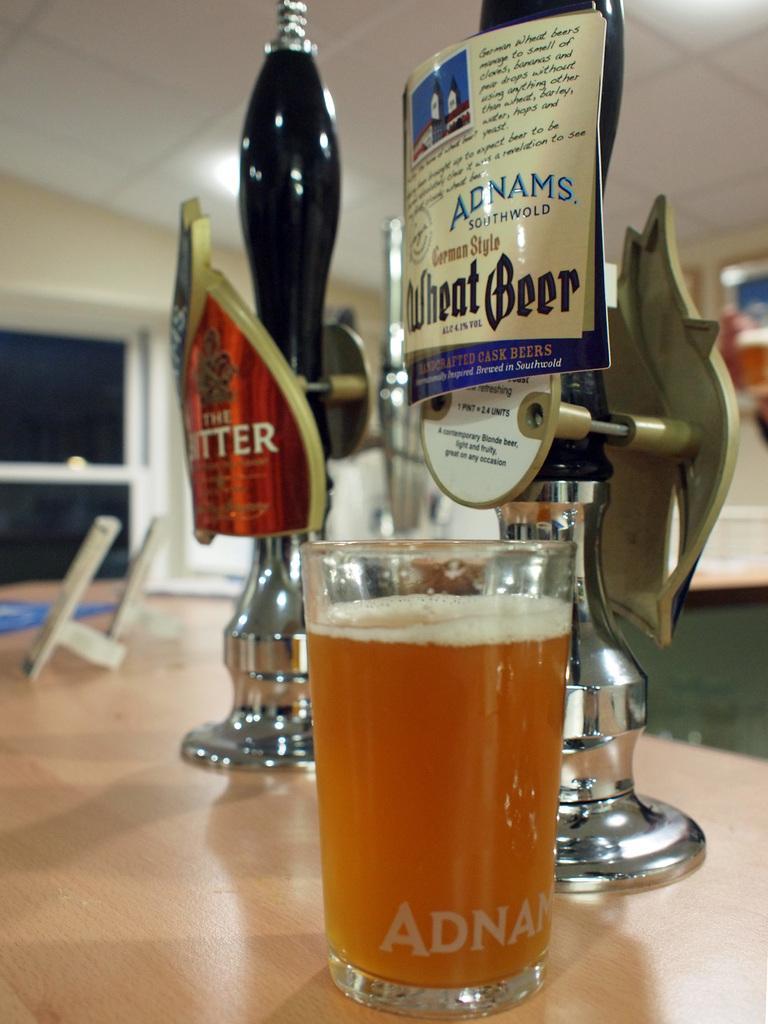Please provide a concise description of this image. In this image, we can see a glass with liquid, few stands with stickers, some objects are placed on the wooden surface. Background there is a blur view. Here there is a door and wall. 